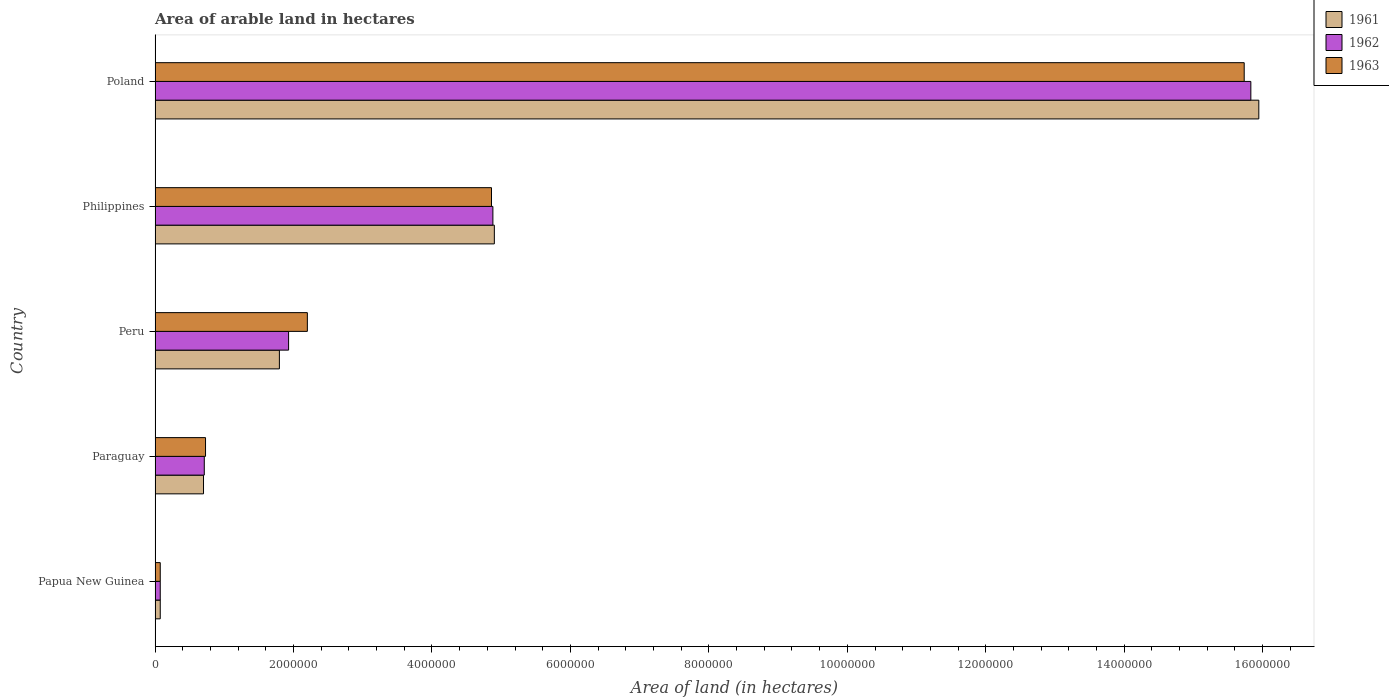How many groups of bars are there?
Your answer should be very brief. 5. Are the number of bars per tick equal to the number of legend labels?
Your answer should be very brief. Yes. How many bars are there on the 5th tick from the top?
Your answer should be very brief. 3. What is the label of the 1st group of bars from the top?
Ensure brevity in your answer.  Poland. What is the total arable land in 1962 in Poland?
Keep it short and to the point. 1.58e+07. Across all countries, what is the maximum total arable land in 1962?
Provide a succinct answer. 1.58e+07. Across all countries, what is the minimum total arable land in 1963?
Your answer should be very brief. 7.50e+04. In which country was the total arable land in 1963 maximum?
Your answer should be very brief. Poland. In which country was the total arable land in 1962 minimum?
Offer a terse response. Papua New Guinea. What is the total total arable land in 1963 in the graph?
Your answer should be very brief. 2.36e+07. What is the difference between the total arable land in 1962 in Peru and that in Poland?
Provide a succinct answer. -1.39e+07. What is the difference between the total arable land in 1962 in Philippines and the total arable land in 1963 in Paraguay?
Your answer should be very brief. 4.15e+06. What is the average total arable land in 1962 per country?
Your answer should be compact. 4.68e+06. What is the difference between the total arable land in 1963 and total arable land in 1961 in Poland?
Offer a very short reply. -2.11e+05. In how many countries, is the total arable land in 1962 greater than 11200000 hectares?
Keep it short and to the point. 1. What is the ratio of the total arable land in 1961 in Philippines to that in Poland?
Offer a terse response. 0.31. Is the total arable land in 1963 in Papua New Guinea less than that in Paraguay?
Your answer should be compact. Yes. What is the difference between the highest and the second highest total arable land in 1963?
Make the answer very short. 1.09e+07. What is the difference between the highest and the lowest total arable land in 1961?
Your response must be concise. 1.59e+07. In how many countries, is the total arable land in 1962 greater than the average total arable land in 1962 taken over all countries?
Give a very brief answer. 2. Is the sum of the total arable land in 1962 in Paraguay and Philippines greater than the maximum total arable land in 1963 across all countries?
Your answer should be compact. No. What does the 2nd bar from the bottom in Papua New Guinea represents?
Provide a succinct answer. 1962. What is the difference between two consecutive major ticks on the X-axis?
Provide a short and direct response. 2.00e+06. Does the graph contain grids?
Provide a succinct answer. No. How are the legend labels stacked?
Offer a terse response. Vertical. What is the title of the graph?
Provide a succinct answer. Area of arable land in hectares. What is the label or title of the X-axis?
Your response must be concise. Area of land (in hectares). What is the Area of land (in hectares) of 1961 in Papua New Guinea?
Your answer should be very brief. 7.50e+04. What is the Area of land (in hectares) in 1962 in Papua New Guinea?
Provide a succinct answer. 7.50e+04. What is the Area of land (in hectares) in 1963 in Papua New Guinea?
Your response must be concise. 7.50e+04. What is the Area of land (in hectares) in 1961 in Paraguay?
Make the answer very short. 7.00e+05. What is the Area of land (in hectares) in 1962 in Paraguay?
Keep it short and to the point. 7.11e+05. What is the Area of land (in hectares) in 1963 in Paraguay?
Your response must be concise. 7.29e+05. What is the Area of land (in hectares) of 1961 in Peru?
Keep it short and to the point. 1.80e+06. What is the Area of land (in hectares) of 1962 in Peru?
Offer a very short reply. 1.93e+06. What is the Area of land (in hectares) of 1963 in Peru?
Provide a succinct answer. 2.20e+06. What is the Area of land (in hectares) in 1961 in Philippines?
Your answer should be very brief. 4.90e+06. What is the Area of land (in hectares) of 1962 in Philippines?
Make the answer very short. 4.88e+06. What is the Area of land (in hectares) of 1963 in Philippines?
Give a very brief answer. 4.86e+06. What is the Area of land (in hectares) in 1961 in Poland?
Offer a terse response. 1.59e+07. What is the Area of land (in hectares) of 1962 in Poland?
Offer a very short reply. 1.58e+07. What is the Area of land (in hectares) in 1963 in Poland?
Your answer should be very brief. 1.57e+07. Across all countries, what is the maximum Area of land (in hectares) of 1961?
Provide a succinct answer. 1.59e+07. Across all countries, what is the maximum Area of land (in hectares) in 1962?
Provide a short and direct response. 1.58e+07. Across all countries, what is the maximum Area of land (in hectares) in 1963?
Offer a terse response. 1.57e+07. Across all countries, what is the minimum Area of land (in hectares) of 1961?
Make the answer very short. 7.50e+04. Across all countries, what is the minimum Area of land (in hectares) of 1962?
Your answer should be very brief. 7.50e+04. Across all countries, what is the minimum Area of land (in hectares) of 1963?
Your answer should be compact. 7.50e+04. What is the total Area of land (in hectares) of 1961 in the graph?
Offer a very short reply. 2.34e+07. What is the total Area of land (in hectares) of 1962 in the graph?
Your response must be concise. 2.34e+07. What is the total Area of land (in hectares) in 1963 in the graph?
Offer a terse response. 2.36e+07. What is the difference between the Area of land (in hectares) of 1961 in Papua New Guinea and that in Paraguay?
Provide a short and direct response. -6.25e+05. What is the difference between the Area of land (in hectares) in 1962 in Papua New Guinea and that in Paraguay?
Offer a very short reply. -6.36e+05. What is the difference between the Area of land (in hectares) in 1963 in Papua New Guinea and that in Paraguay?
Provide a succinct answer. -6.54e+05. What is the difference between the Area of land (in hectares) of 1961 in Papua New Guinea and that in Peru?
Offer a very short reply. -1.72e+06. What is the difference between the Area of land (in hectares) of 1962 in Papua New Guinea and that in Peru?
Offer a terse response. -1.85e+06. What is the difference between the Area of land (in hectares) in 1963 in Papua New Guinea and that in Peru?
Offer a very short reply. -2.12e+06. What is the difference between the Area of land (in hectares) in 1961 in Papua New Guinea and that in Philippines?
Give a very brief answer. -4.83e+06. What is the difference between the Area of land (in hectares) in 1962 in Papua New Guinea and that in Philippines?
Keep it short and to the point. -4.80e+06. What is the difference between the Area of land (in hectares) in 1963 in Papua New Guinea and that in Philippines?
Ensure brevity in your answer.  -4.78e+06. What is the difference between the Area of land (in hectares) in 1961 in Papua New Guinea and that in Poland?
Give a very brief answer. -1.59e+07. What is the difference between the Area of land (in hectares) of 1962 in Papua New Guinea and that in Poland?
Keep it short and to the point. -1.58e+07. What is the difference between the Area of land (in hectares) in 1963 in Papua New Guinea and that in Poland?
Your answer should be very brief. -1.57e+07. What is the difference between the Area of land (in hectares) of 1961 in Paraguay and that in Peru?
Your response must be concise. -1.10e+06. What is the difference between the Area of land (in hectares) of 1962 in Paraguay and that in Peru?
Give a very brief answer. -1.22e+06. What is the difference between the Area of land (in hectares) of 1963 in Paraguay and that in Peru?
Provide a succinct answer. -1.47e+06. What is the difference between the Area of land (in hectares) in 1961 in Paraguay and that in Philippines?
Offer a terse response. -4.20e+06. What is the difference between the Area of land (in hectares) of 1962 in Paraguay and that in Philippines?
Give a very brief answer. -4.17e+06. What is the difference between the Area of land (in hectares) of 1963 in Paraguay and that in Philippines?
Offer a very short reply. -4.13e+06. What is the difference between the Area of land (in hectares) in 1961 in Paraguay and that in Poland?
Offer a very short reply. -1.52e+07. What is the difference between the Area of land (in hectares) of 1962 in Paraguay and that in Poland?
Your response must be concise. -1.51e+07. What is the difference between the Area of land (in hectares) in 1963 in Paraguay and that in Poland?
Your answer should be very brief. -1.50e+07. What is the difference between the Area of land (in hectares) in 1961 in Peru and that in Philippines?
Offer a very short reply. -3.10e+06. What is the difference between the Area of land (in hectares) in 1962 in Peru and that in Philippines?
Your response must be concise. -2.95e+06. What is the difference between the Area of land (in hectares) in 1963 in Peru and that in Philippines?
Keep it short and to the point. -2.66e+06. What is the difference between the Area of land (in hectares) of 1961 in Peru and that in Poland?
Your answer should be compact. -1.41e+07. What is the difference between the Area of land (in hectares) of 1962 in Peru and that in Poland?
Keep it short and to the point. -1.39e+07. What is the difference between the Area of land (in hectares) of 1963 in Peru and that in Poland?
Ensure brevity in your answer.  -1.35e+07. What is the difference between the Area of land (in hectares) of 1961 in Philippines and that in Poland?
Your answer should be compact. -1.10e+07. What is the difference between the Area of land (in hectares) in 1962 in Philippines and that in Poland?
Keep it short and to the point. -1.09e+07. What is the difference between the Area of land (in hectares) of 1963 in Philippines and that in Poland?
Make the answer very short. -1.09e+07. What is the difference between the Area of land (in hectares) of 1961 in Papua New Guinea and the Area of land (in hectares) of 1962 in Paraguay?
Make the answer very short. -6.36e+05. What is the difference between the Area of land (in hectares) of 1961 in Papua New Guinea and the Area of land (in hectares) of 1963 in Paraguay?
Your response must be concise. -6.54e+05. What is the difference between the Area of land (in hectares) in 1962 in Papua New Guinea and the Area of land (in hectares) in 1963 in Paraguay?
Ensure brevity in your answer.  -6.54e+05. What is the difference between the Area of land (in hectares) in 1961 in Papua New Guinea and the Area of land (in hectares) in 1962 in Peru?
Ensure brevity in your answer.  -1.85e+06. What is the difference between the Area of land (in hectares) in 1961 in Papua New Guinea and the Area of land (in hectares) in 1963 in Peru?
Your answer should be compact. -2.12e+06. What is the difference between the Area of land (in hectares) of 1962 in Papua New Guinea and the Area of land (in hectares) of 1963 in Peru?
Offer a terse response. -2.12e+06. What is the difference between the Area of land (in hectares) of 1961 in Papua New Guinea and the Area of land (in hectares) of 1962 in Philippines?
Give a very brief answer. -4.80e+06. What is the difference between the Area of land (in hectares) in 1961 in Papua New Guinea and the Area of land (in hectares) in 1963 in Philippines?
Offer a very short reply. -4.78e+06. What is the difference between the Area of land (in hectares) of 1962 in Papua New Guinea and the Area of land (in hectares) of 1963 in Philippines?
Your response must be concise. -4.78e+06. What is the difference between the Area of land (in hectares) of 1961 in Papua New Guinea and the Area of land (in hectares) of 1962 in Poland?
Keep it short and to the point. -1.58e+07. What is the difference between the Area of land (in hectares) of 1961 in Papua New Guinea and the Area of land (in hectares) of 1963 in Poland?
Give a very brief answer. -1.57e+07. What is the difference between the Area of land (in hectares) in 1962 in Papua New Guinea and the Area of land (in hectares) in 1963 in Poland?
Ensure brevity in your answer.  -1.57e+07. What is the difference between the Area of land (in hectares) in 1961 in Paraguay and the Area of land (in hectares) in 1962 in Peru?
Offer a very short reply. -1.23e+06. What is the difference between the Area of land (in hectares) in 1961 in Paraguay and the Area of land (in hectares) in 1963 in Peru?
Offer a very short reply. -1.50e+06. What is the difference between the Area of land (in hectares) in 1962 in Paraguay and the Area of land (in hectares) in 1963 in Peru?
Offer a very short reply. -1.49e+06. What is the difference between the Area of land (in hectares) of 1961 in Paraguay and the Area of land (in hectares) of 1962 in Philippines?
Provide a short and direct response. -4.18e+06. What is the difference between the Area of land (in hectares) of 1961 in Paraguay and the Area of land (in hectares) of 1963 in Philippines?
Provide a succinct answer. -4.16e+06. What is the difference between the Area of land (in hectares) in 1962 in Paraguay and the Area of land (in hectares) in 1963 in Philippines?
Offer a terse response. -4.15e+06. What is the difference between the Area of land (in hectares) in 1961 in Paraguay and the Area of land (in hectares) in 1962 in Poland?
Your answer should be compact. -1.51e+07. What is the difference between the Area of land (in hectares) in 1961 in Paraguay and the Area of land (in hectares) in 1963 in Poland?
Provide a succinct answer. -1.50e+07. What is the difference between the Area of land (in hectares) of 1962 in Paraguay and the Area of land (in hectares) of 1963 in Poland?
Ensure brevity in your answer.  -1.50e+07. What is the difference between the Area of land (in hectares) of 1961 in Peru and the Area of land (in hectares) of 1962 in Philippines?
Offer a very short reply. -3.08e+06. What is the difference between the Area of land (in hectares) in 1961 in Peru and the Area of land (in hectares) in 1963 in Philippines?
Your response must be concise. -3.06e+06. What is the difference between the Area of land (in hectares) of 1962 in Peru and the Area of land (in hectares) of 1963 in Philippines?
Your response must be concise. -2.93e+06. What is the difference between the Area of land (in hectares) of 1961 in Peru and the Area of land (in hectares) of 1962 in Poland?
Provide a short and direct response. -1.40e+07. What is the difference between the Area of land (in hectares) of 1961 in Peru and the Area of land (in hectares) of 1963 in Poland?
Give a very brief answer. -1.39e+07. What is the difference between the Area of land (in hectares) in 1962 in Peru and the Area of land (in hectares) in 1963 in Poland?
Your answer should be very brief. -1.38e+07. What is the difference between the Area of land (in hectares) of 1961 in Philippines and the Area of land (in hectares) of 1962 in Poland?
Offer a terse response. -1.09e+07. What is the difference between the Area of land (in hectares) in 1961 in Philippines and the Area of land (in hectares) in 1963 in Poland?
Provide a short and direct response. -1.08e+07. What is the difference between the Area of land (in hectares) of 1962 in Philippines and the Area of land (in hectares) of 1963 in Poland?
Offer a terse response. -1.09e+07. What is the average Area of land (in hectares) in 1961 per country?
Your answer should be compact. 4.68e+06. What is the average Area of land (in hectares) in 1962 per country?
Keep it short and to the point. 4.68e+06. What is the average Area of land (in hectares) of 1963 per country?
Offer a very short reply. 4.72e+06. What is the difference between the Area of land (in hectares) in 1961 and Area of land (in hectares) in 1962 in Papua New Guinea?
Provide a short and direct response. 0. What is the difference between the Area of land (in hectares) in 1961 and Area of land (in hectares) in 1963 in Papua New Guinea?
Your answer should be very brief. 0. What is the difference between the Area of land (in hectares) of 1962 and Area of land (in hectares) of 1963 in Papua New Guinea?
Your response must be concise. 0. What is the difference between the Area of land (in hectares) of 1961 and Area of land (in hectares) of 1962 in Paraguay?
Keep it short and to the point. -1.10e+04. What is the difference between the Area of land (in hectares) of 1961 and Area of land (in hectares) of 1963 in Paraguay?
Ensure brevity in your answer.  -2.90e+04. What is the difference between the Area of land (in hectares) in 1962 and Area of land (in hectares) in 1963 in Paraguay?
Your answer should be very brief. -1.80e+04. What is the difference between the Area of land (in hectares) in 1961 and Area of land (in hectares) in 1962 in Peru?
Offer a very short reply. -1.33e+05. What is the difference between the Area of land (in hectares) of 1961 and Area of land (in hectares) of 1963 in Peru?
Offer a terse response. -4.04e+05. What is the difference between the Area of land (in hectares) of 1962 and Area of land (in hectares) of 1963 in Peru?
Your answer should be compact. -2.71e+05. What is the difference between the Area of land (in hectares) in 1961 and Area of land (in hectares) in 1962 in Philippines?
Give a very brief answer. 2.10e+04. What is the difference between the Area of land (in hectares) of 1961 and Area of land (in hectares) of 1963 in Philippines?
Provide a succinct answer. 4.10e+04. What is the difference between the Area of land (in hectares) of 1961 and Area of land (in hectares) of 1962 in Poland?
Provide a short and direct response. 1.15e+05. What is the difference between the Area of land (in hectares) in 1961 and Area of land (in hectares) in 1963 in Poland?
Your answer should be compact. 2.11e+05. What is the difference between the Area of land (in hectares) of 1962 and Area of land (in hectares) of 1963 in Poland?
Offer a terse response. 9.60e+04. What is the ratio of the Area of land (in hectares) of 1961 in Papua New Guinea to that in Paraguay?
Your answer should be compact. 0.11. What is the ratio of the Area of land (in hectares) of 1962 in Papua New Guinea to that in Paraguay?
Ensure brevity in your answer.  0.11. What is the ratio of the Area of land (in hectares) of 1963 in Papua New Guinea to that in Paraguay?
Offer a very short reply. 0.1. What is the ratio of the Area of land (in hectares) of 1961 in Papua New Guinea to that in Peru?
Provide a short and direct response. 0.04. What is the ratio of the Area of land (in hectares) in 1962 in Papua New Guinea to that in Peru?
Keep it short and to the point. 0.04. What is the ratio of the Area of land (in hectares) of 1963 in Papua New Guinea to that in Peru?
Ensure brevity in your answer.  0.03. What is the ratio of the Area of land (in hectares) in 1961 in Papua New Guinea to that in Philippines?
Your response must be concise. 0.02. What is the ratio of the Area of land (in hectares) of 1962 in Papua New Guinea to that in Philippines?
Your answer should be compact. 0.02. What is the ratio of the Area of land (in hectares) of 1963 in Papua New Guinea to that in Philippines?
Give a very brief answer. 0.02. What is the ratio of the Area of land (in hectares) in 1961 in Papua New Guinea to that in Poland?
Make the answer very short. 0. What is the ratio of the Area of land (in hectares) in 1962 in Papua New Guinea to that in Poland?
Your answer should be very brief. 0. What is the ratio of the Area of land (in hectares) of 1963 in Papua New Guinea to that in Poland?
Offer a very short reply. 0. What is the ratio of the Area of land (in hectares) in 1961 in Paraguay to that in Peru?
Offer a very short reply. 0.39. What is the ratio of the Area of land (in hectares) in 1962 in Paraguay to that in Peru?
Offer a very short reply. 0.37. What is the ratio of the Area of land (in hectares) in 1963 in Paraguay to that in Peru?
Offer a terse response. 0.33. What is the ratio of the Area of land (in hectares) of 1961 in Paraguay to that in Philippines?
Keep it short and to the point. 0.14. What is the ratio of the Area of land (in hectares) in 1962 in Paraguay to that in Philippines?
Provide a short and direct response. 0.15. What is the ratio of the Area of land (in hectares) in 1963 in Paraguay to that in Philippines?
Your answer should be compact. 0.15. What is the ratio of the Area of land (in hectares) in 1961 in Paraguay to that in Poland?
Offer a very short reply. 0.04. What is the ratio of the Area of land (in hectares) of 1962 in Paraguay to that in Poland?
Ensure brevity in your answer.  0.04. What is the ratio of the Area of land (in hectares) of 1963 in Paraguay to that in Poland?
Ensure brevity in your answer.  0.05. What is the ratio of the Area of land (in hectares) in 1961 in Peru to that in Philippines?
Keep it short and to the point. 0.37. What is the ratio of the Area of land (in hectares) in 1962 in Peru to that in Philippines?
Provide a short and direct response. 0.4. What is the ratio of the Area of land (in hectares) of 1963 in Peru to that in Philippines?
Your answer should be very brief. 0.45. What is the ratio of the Area of land (in hectares) in 1961 in Peru to that in Poland?
Offer a very short reply. 0.11. What is the ratio of the Area of land (in hectares) of 1962 in Peru to that in Poland?
Offer a very short reply. 0.12. What is the ratio of the Area of land (in hectares) of 1963 in Peru to that in Poland?
Make the answer very short. 0.14. What is the ratio of the Area of land (in hectares) of 1961 in Philippines to that in Poland?
Your response must be concise. 0.31. What is the ratio of the Area of land (in hectares) of 1962 in Philippines to that in Poland?
Offer a very short reply. 0.31. What is the ratio of the Area of land (in hectares) in 1963 in Philippines to that in Poland?
Provide a short and direct response. 0.31. What is the difference between the highest and the second highest Area of land (in hectares) of 1961?
Provide a succinct answer. 1.10e+07. What is the difference between the highest and the second highest Area of land (in hectares) of 1962?
Your answer should be compact. 1.09e+07. What is the difference between the highest and the second highest Area of land (in hectares) of 1963?
Your answer should be very brief. 1.09e+07. What is the difference between the highest and the lowest Area of land (in hectares) in 1961?
Make the answer very short. 1.59e+07. What is the difference between the highest and the lowest Area of land (in hectares) of 1962?
Ensure brevity in your answer.  1.58e+07. What is the difference between the highest and the lowest Area of land (in hectares) of 1963?
Your answer should be compact. 1.57e+07. 